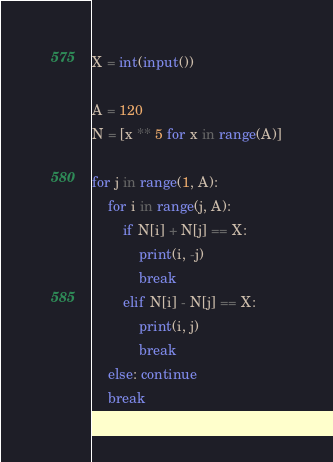<code> <loc_0><loc_0><loc_500><loc_500><_Python_>X = int(input())

A = 120
N = [x ** 5 for x in range(A)]

for j in range(1, A):
    for i in range(j, A):
        if N[i] + N[j] == X:
            print(i, -j)
            break
        elif N[i] - N[j] == X:
            print(i, j)
            break
    else: continue
    break</code> 